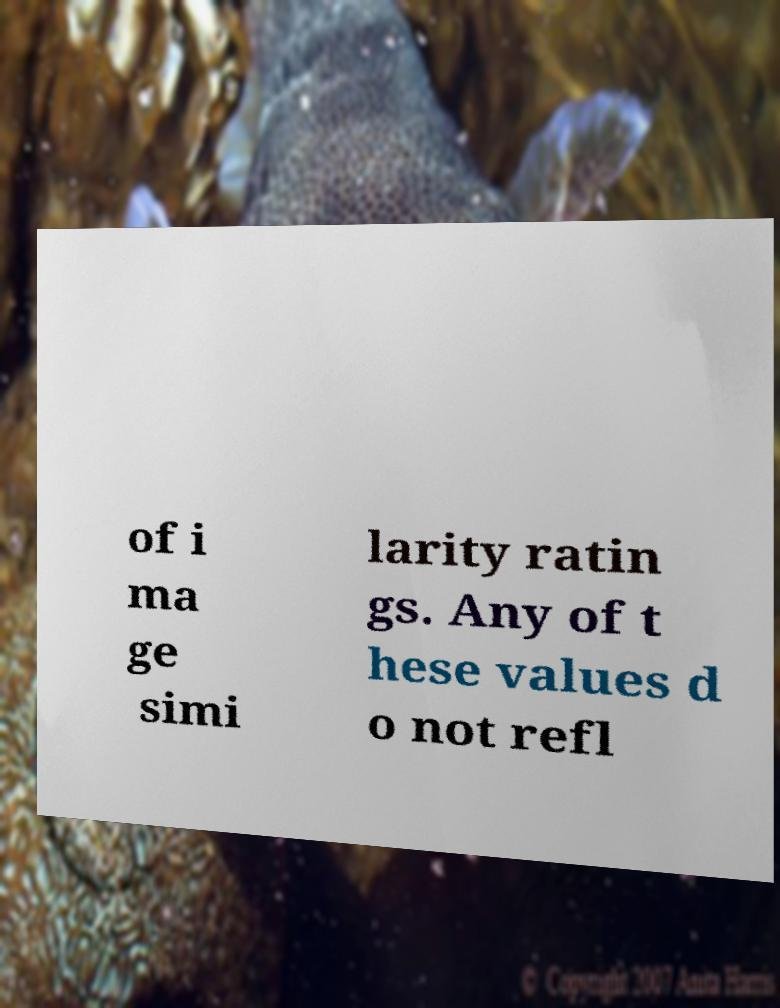There's text embedded in this image that I need extracted. Can you transcribe it verbatim? of i ma ge simi larity ratin gs. Any of t hese values d o not refl 